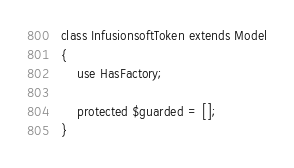<code> <loc_0><loc_0><loc_500><loc_500><_PHP_>
class InfusionsoftToken extends Model
{
    use HasFactory;

    protected $guarded = [];
}
</code> 